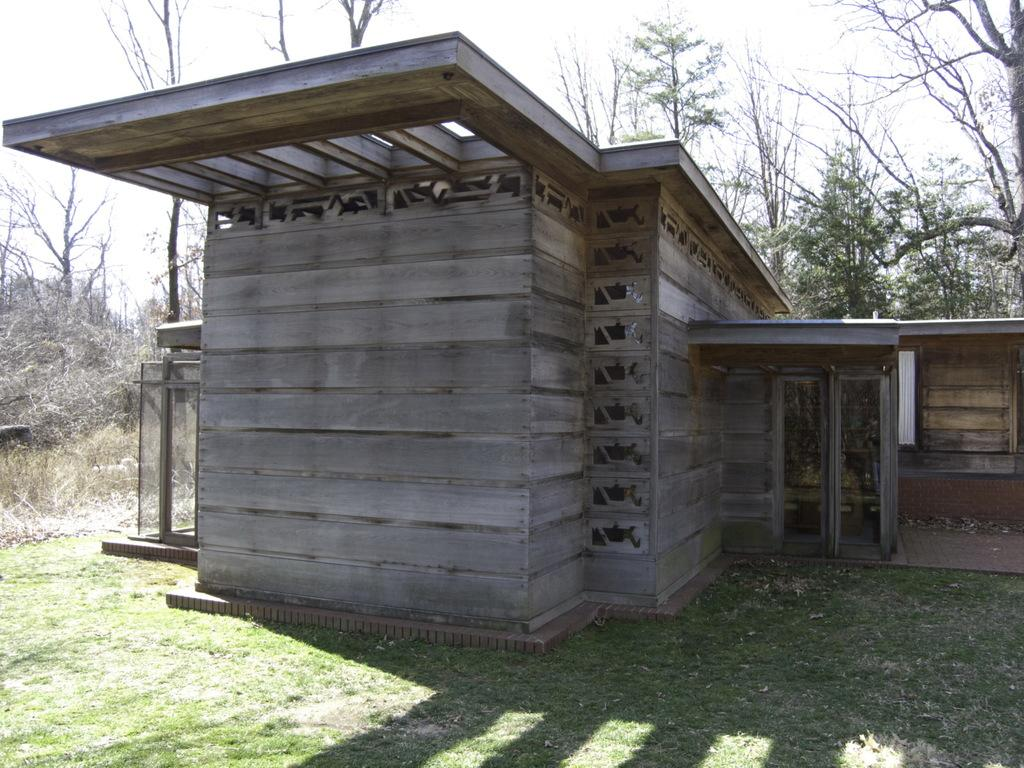What type of house is in the middle of the image? There is a wooden house in the middle of the image. What can be seen in the background of the image? There are trees in the background of the image. What is on the ground in the image? There is grass on the ground in the image. What is visible at the top of the image? The sky is visible at the top of the image. What color is the thumb of the person in the image? There is no person present in the image, so there is no thumb to observe. 